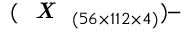<formula> <loc_0><loc_0><loc_500><loc_500>( X _ { ( 5 6 \times 1 1 2 \times 4 ) } )</formula> 